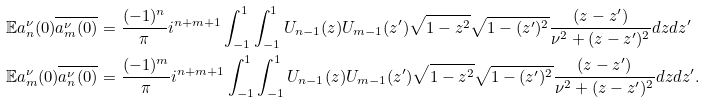<formula> <loc_0><loc_0><loc_500><loc_500>\mathbb { E } a _ { n } ^ { \nu } ( 0 ) \overline { a _ { m } ^ { \nu } ( 0 ) } & = \frac { ( - 1 ) ^ { n } } { \pi } i ^ { n + m + 1 } \int _ { - 1 } ^ { 1 } \int _ { - 1 } ^ { 1 } U _ { n - 1 } ( z ) U _ { m - 1 } ( z ^ { \prime } ) \sqrt { 1 - z ^ { 2 } } \sqrt { 1 - ( z ^ { \prime } ) ^ { 2 } } \frac { ( z - z ^ { \prime } ) } { \nu ^ { 2 } + ( z - z ^ { \prime } ) ^ { 2 } } d z d z ^ { \prime } \\ \mathbb { E } a _ { m } ^ { \nu } ( 0 ) \overline { a _ { n } ^ { \nu } ( 0 ) } & = \frac { ( - 1 ) ^ { m } } { \pi } i ^ { n + m + 1 } \int _ { - 1 } ^ { 1 } \int _ { - 1 } ^ { 1 } U _ { n - 1 } ( z ) U _ { m - 1 } ( z ^ { \prime } ) \sqrt { 1 - z ^ { 2 } } \sqrt { 1 - ( z ^ { \prime } ) ^ { 2 } } \frac { ( z - z ^ { \prime } ) } { \nu ^ { 2 } + ( z - z ^ { \prime } ) ^ { 2 } } d z d z ^ { \prime } .</formula> 